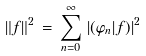<formula> <loc_0><loc_0><loc_500><loc_500>\| f \| ^ { 2 } \, = \, \sum _ { n = 0 } ^ { \infty } \, | ( \varphi _ { n } | f ) | ^ { 2 }</formula> 